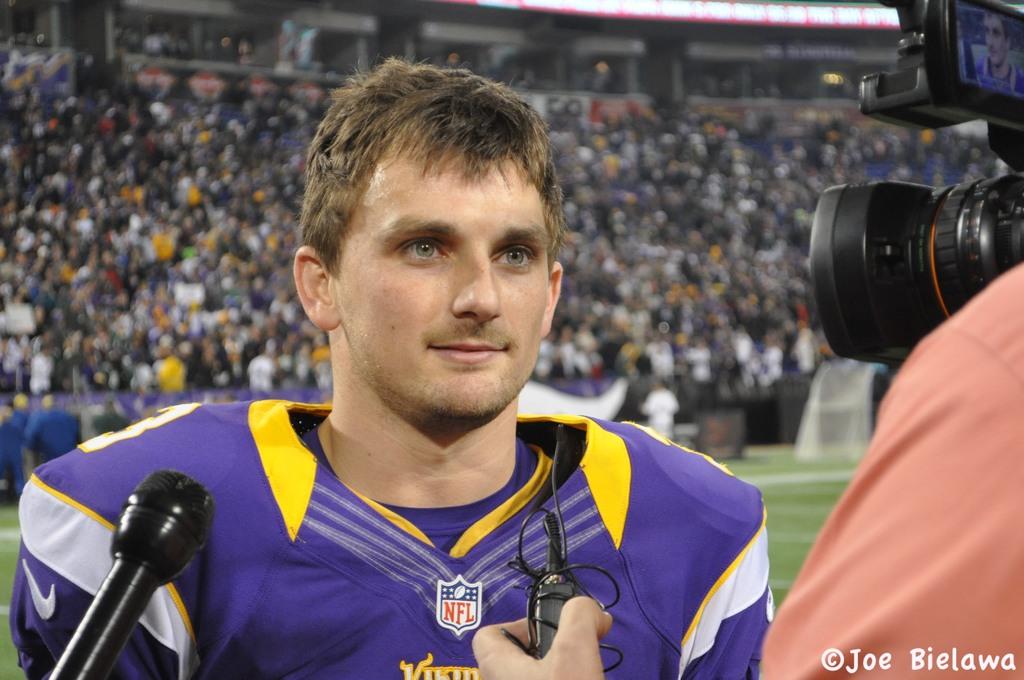Who is copywrited with taking this?
Your answer should be very brief. Joe bielawa. 